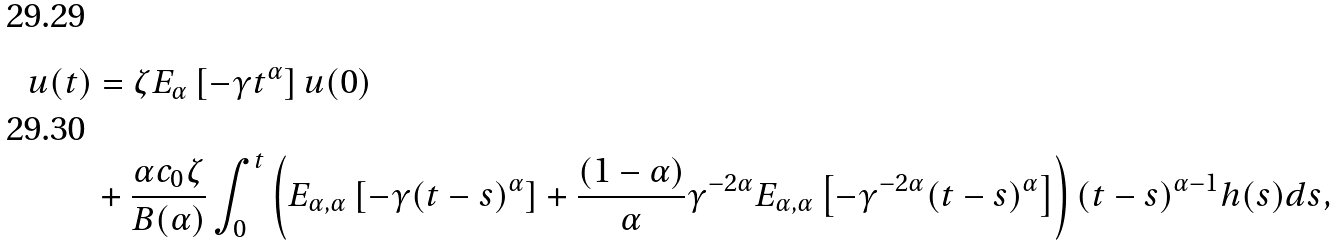Convert formula to latex. <formula><loc_0><loc_0><loc_500><loc_500>u ( t ) & = \zeta E _ { \alpha } \left [ - \gamma t ^ { \alpha } \right ] u ( 0 ) \\ & + \frac { \alpha c _ { 0 } \zeta } { B ( \alpha ) } \int _ { 0 } ^ { t } \left ( E _ { \alpha , \alpha } \left [ - \gamma ( t - s ) ^ { \alpha } \right ] + \frac { ( 1 - \alpha ) } { \alpha } \gamma ^ { - 2 \alpha } E _ { \alpha , \alpha } \left [ - \gamma ^ { - 2 \alpha } ( t - s ) ^ { \alpha } \right ] \right ) ( t - s ) ^ { \alpha - 1 } h ( s ) d s ,</formula> 